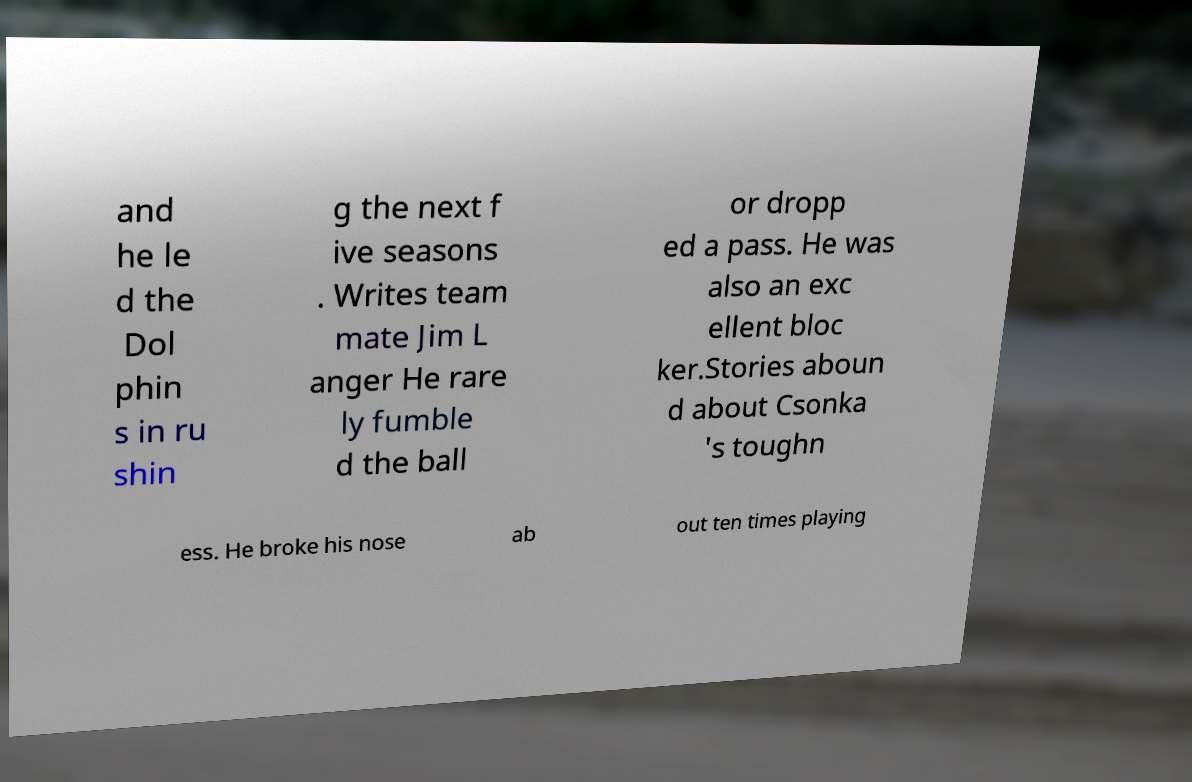Can you accurately transcribe the text from the provided image for me? and he le d the Dol phin s in ru shin g the next f ive seasons . Writes team mate Jim L anger He rare ly fumble d the ball or dropp ed a pass. He was also an exc ellent bloc ker.Stories aboun d about Csonka 's toughn ess. He broke his nose ab out ten times playing 